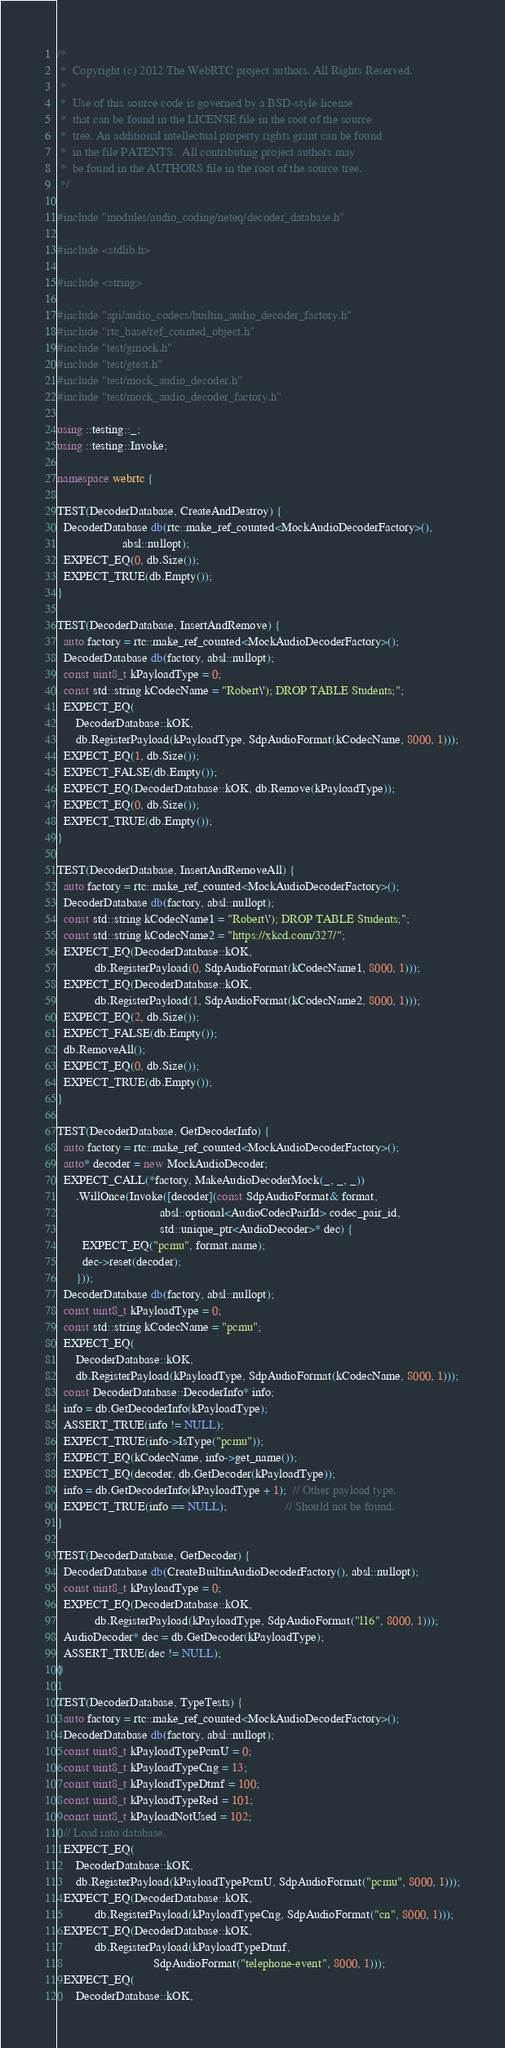<code> <loc_0><loc_0><loc_500><loc_500><_C++_>/*
 *  Copyright (c) 2012 The WebRTC project authors. All Rights Reserved.
 *
 *  Use of this source code is governed by a BSD-style license
 *  that can be found in the LICENSE file in the root of the source
 *  tree. An additional intellectual property rights grant can be found
 *  in the file PATENTS.  All contributing project authors may
 *  be found in the AUTHORS file in the root of the source tree.
 */

#include "modules/audio_coding/neteq/decoder_database.h"

#include <stdlib.h>

#include <string>

#include "api/audio_codecs/builtin_audio_decoder_factory.h"
#include "rtc_base/ref_counted_object.h"
#include "test/gmock.h"
#include "test/gtest.h"
#include "test/mock_audio_decoder.h"
#include "test/mock_audio_decoder_factory.h"

using ::testing::_;
using ::testing::Invoke;

namespace webrtc {

TEST(DecoderDatabase, CreateAndDestroy) {
  DecoderDatabase db(rtc::make_ref_counted<MockAudioDecoderFactory>(),
                     absl::nullopt);
  EXPECT_EQ(0, db.Size());
  EXPECT_TRUE(db.Empty());
}

TEST(DecoderDatabase, InsertAndRemove) {
  auto factory = rtc::make_ref_counted<MockAudioDecoderFactory>();
  DecoderDatabase db(factory, absl::nullopt);
  const uint8_t kPayloadType = 0;
  const std::string kCodecName = "Robert\'); DROP TABLE Students;";
  EXPECT_EQ(
      DecoderDatabase::kOK,
      db.RegisterPayload(kPayloadType, SdpAudioFormat(kCodecName, 8000, 1)));
  EXPECT_EQ(1, db.Size());
  EXPECT_FALSE(db.Empty());
  EXPECT_EQ(DecoderDatabase::kOK, db.Remove(kPayloadType));
  EXPECT_EQ(0, db.Size());
  EXPECT_TRUE(db.Empty());
}

TEST(DecoderDatabase, InsertAndRemoveAll) {
  auto factory = rtc::make_ref_counted<MockAudioDecoderFactory>();
  DecoderDatabase db(factory, absl::nullopt);
  const std::string kCodecName1 = "Robert\'); DROP TABLE Students;";
  const std::string kCodecName2 = "https://xkcd.com/327/";
  EXPECT_EQ(DecoderDatabase::kOK,
            db.RegisterPayload(0, SdpAudioFormat(kCodecName1, 8000, 1)));
  EXPECT_EQ(DecoderDatabase::kOK,
            db.RegisterPayload(1, SdpAudioFormat(kCodecName2, 8000, 1)));
  EXPECT_EQ(2, db.Size());
  EXPECT_FALSE(db.Empty());
  db.RemoveAll();
  EXPECT_EQ(0, db.Size());
  EXPECT_TRUE(db.Empty());
}

TEST(DecoderDatabase, GetDecoderInfo) {
  auto factory = rtc::make_ref_counted<MockAudioDecoderFactory>();
  auto* decoder = new MockAudioDecoder;
  EXPECT_CALL(*factory, MakeAudioDecoderMock(_, _, _))
      .WillOnce(Invoke([decoder](const SdpAudioFormat& format,
                                 absl::optional<AudioCodecPairId> codec_pair_id,
                                 std::unique_ptr<AudioDecoder>* dec) {
        EXPECT_EQ("pcmu", format.name);
        dec->reset(decoder);
      }));
  DecoderDatabase db(factory, absl::nullopt);
  const uint8_t kPayloadType = 0;
  const std::string kCodecName = "pcmu";
  EXPECT_EQ(
      DecoderDatabase::kOK,
      db.RegisterPayload(kPayloadType, SdpAudioFormat(kCodecName, 8000, 1)));
  const DecoderDatabase::DecoderInfo* info;
  info = db.GetDecoderInfo(kPayloadType);
  ASSERT_TRUE(info != NULL);
  EXPECT_TRUE(info->IsType("pcmu"));
  EXPECT_EQ(kCodecName, info->get_name());
  EXPECT_EQ(decoder, db.GetDecoder(kPayloadType));
  info = db.GetDecoderInfo(kPayloadType + 1);  // Other payload type.
  EXPECT_TRUE(info == NULL);                   // Should not be found.
}

TEST(DecoderDatabase, GetDecoder) {
  DecoderDatabase db(CreateBuiltinAudioDecoderFactory(), absl::nullopt);
  const uint8_t kPayloadType = 0;
  EXPECT_EQ(DecoderDatabase::kOK,
            db.RegisterPayload(kPayloadType, SdpAudioFormat("l16", 8000, 1)));
  AudioDecoder* dec = db.GetDecoder(kPayloadType);
  ASSERT_TRUE(dec != NULL);
}

TEST(DecoderDatabase, TypeTests) {
  auto factory = rtc::make_ref_counted<MockAudioDecoderFactory>();
  DecoderDatabase db(factory, absl::nullopt);
  const uint8_t kPayloadTypePcmU = 0;
  const uint8_t kPayloadTypeCng = 13;
  const uint8_t kPayloadTypeDtmf = 100;
  const uint8_t kPayloadTypeRed = 101;
  const uint8_t kPayloadNotUsed = 102;
  // Load into database.
  EXPECT_EQ(
      DecoderDatabase::kOK,
      db.RegisterPayload(kPayloadTypePcmU, SdpAudioFormat("pcmu", 8000, 1)));
  EXPECT_EQ(DecoderDatabase::kOK,
            db.RegisterPayload(kPayloadTypeCng, SdpAudioFormat("cn", 8000, 1)));
  EXPECT_EQ(DecoderDatabase::kOK,
            db.RegisterPayload(kPayloadTypeDtmf,
                               SdpAudioFormat("telephone-event", 8000, 1)));
  EXPECT_EQ(
      DecoderDatabase::kOK,</code> 